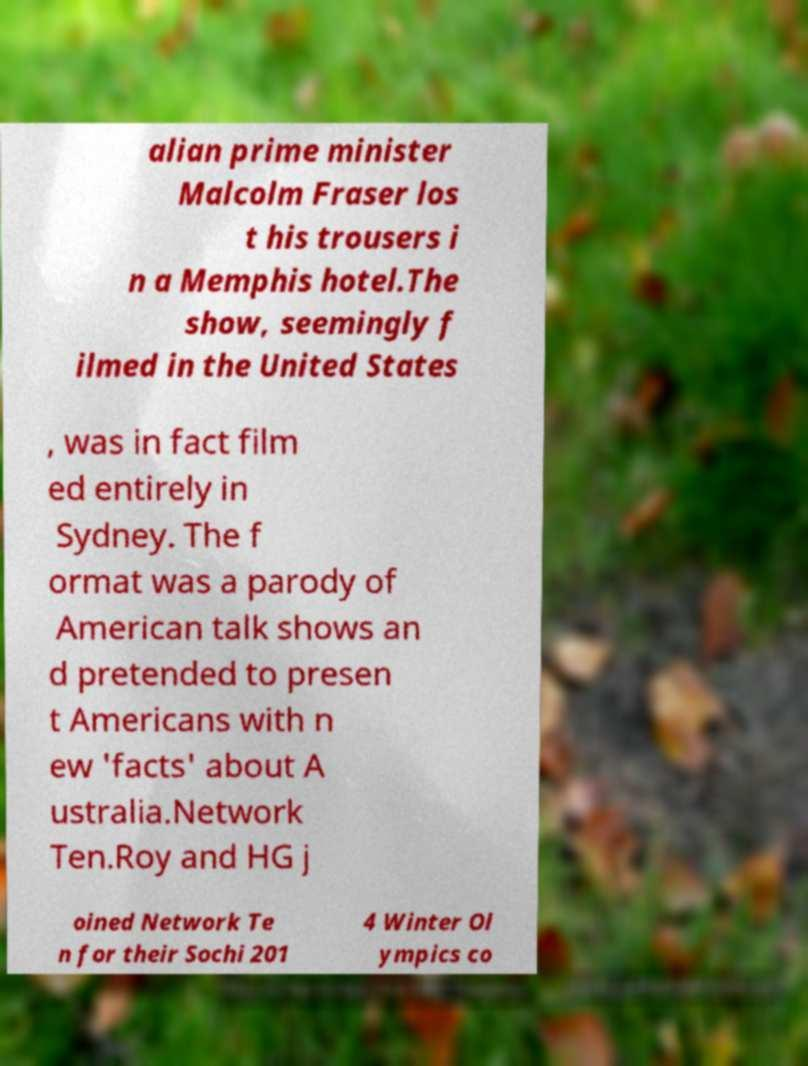Can you accurately transcribe the text from the provided image for me? alian prime minister Malcolm Fraser los t his trousers i n a Memphis hotel.The show, seemingly f ilmed in the United States , was in fact film ed entirely in Sydney. The f ormat was a parody of American talk shows an d pretended to presen t Americans with n ew 'facts' about A ustralia.Network Ten.Roy and HG j oined Network Te n for their Sochi 201 4 Winter Ol ympics co 